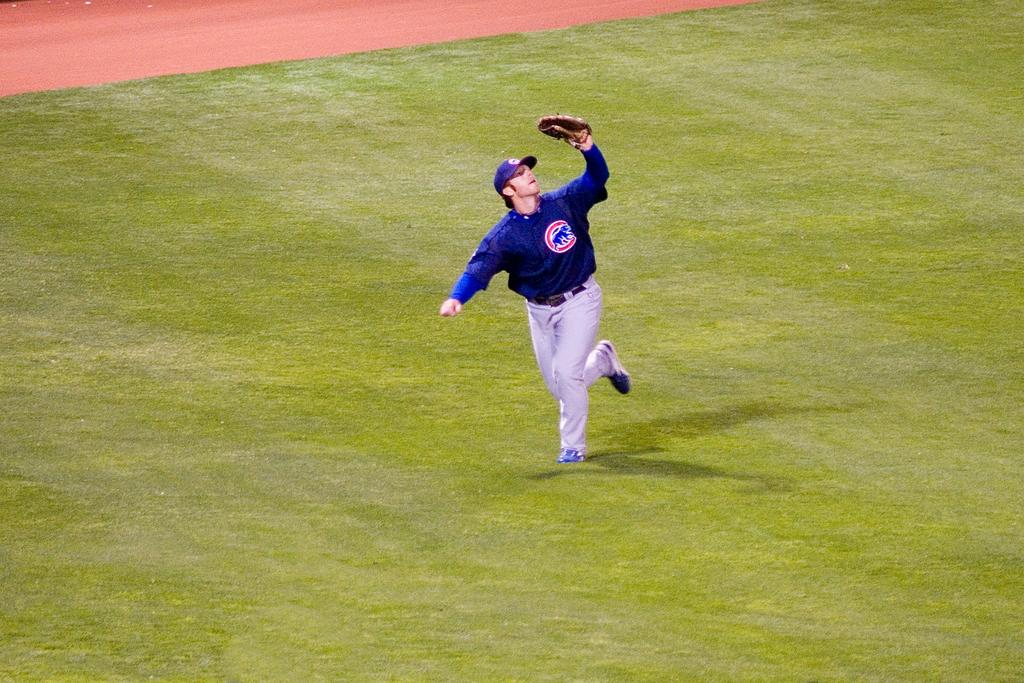What is happening in the image? There is a person in the image, and they are running on the grass. What is the person holding while running? The person is holding an object. What type of test is the person taking while running in the image? There is no test present in the image; the person is simply running on the grass while holding an object. 